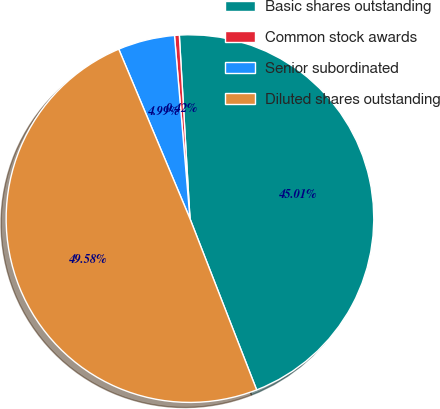Convert chart to OTSL. <chart><loc_0><loc_0><loc_500><loc_500><pie_chart><fcel>Basic shares outstanding<fcel>Common stock awards<fcel>Senior subordinated<fcel>Diluted shares outstanding<nl><fcel>45.01%<fcel>0.42%<fcel>4.99%<fcel>49.58%<nl></chart> 